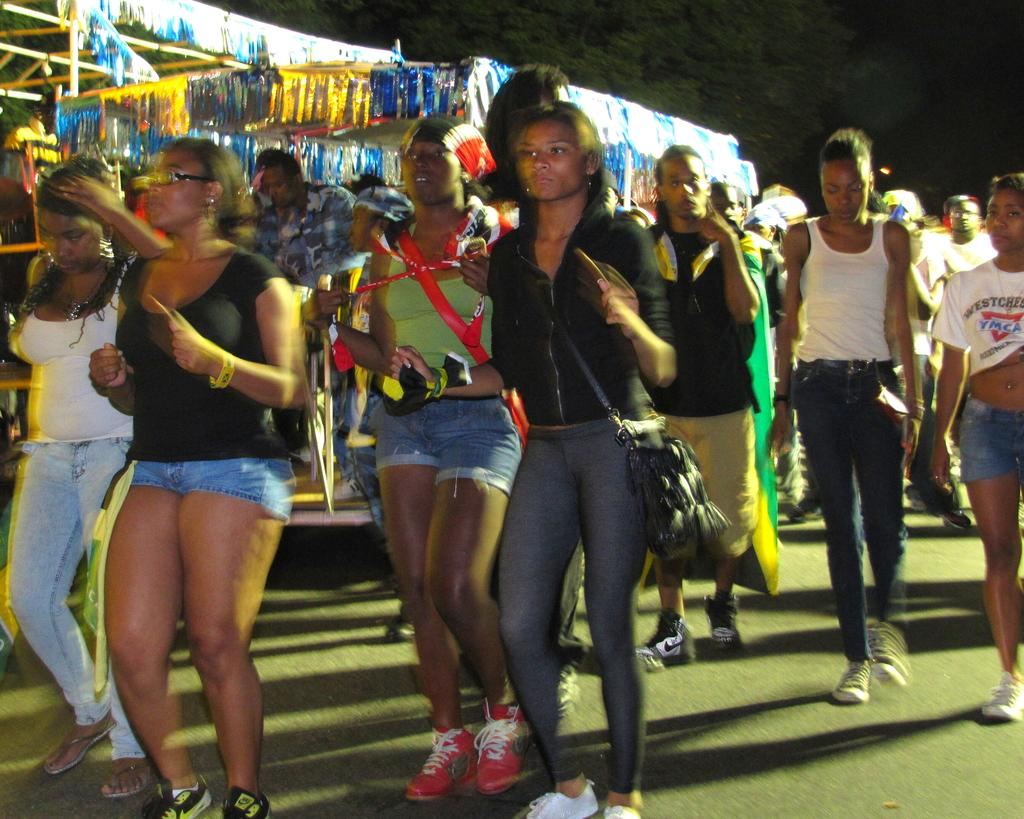What can be seen in the image involving multiple individuals? There is a group of people in the image. What objects are present that resemble long, thin bars? There are rods in the image. What type of objects are present that serve a decorative purpose? There are decorative objects in the image. How would you describe the lighting or color of the background in the image? The background of the image is dark. What type of reaction can be seen from the plantation in the image? There is no plantation present in the image, so it is not possible to observe any reactions from it. What flavor or taste can be detected from the decorative objects in the image? The decorative objects in the image are not associated with any specific taste or flavor. 